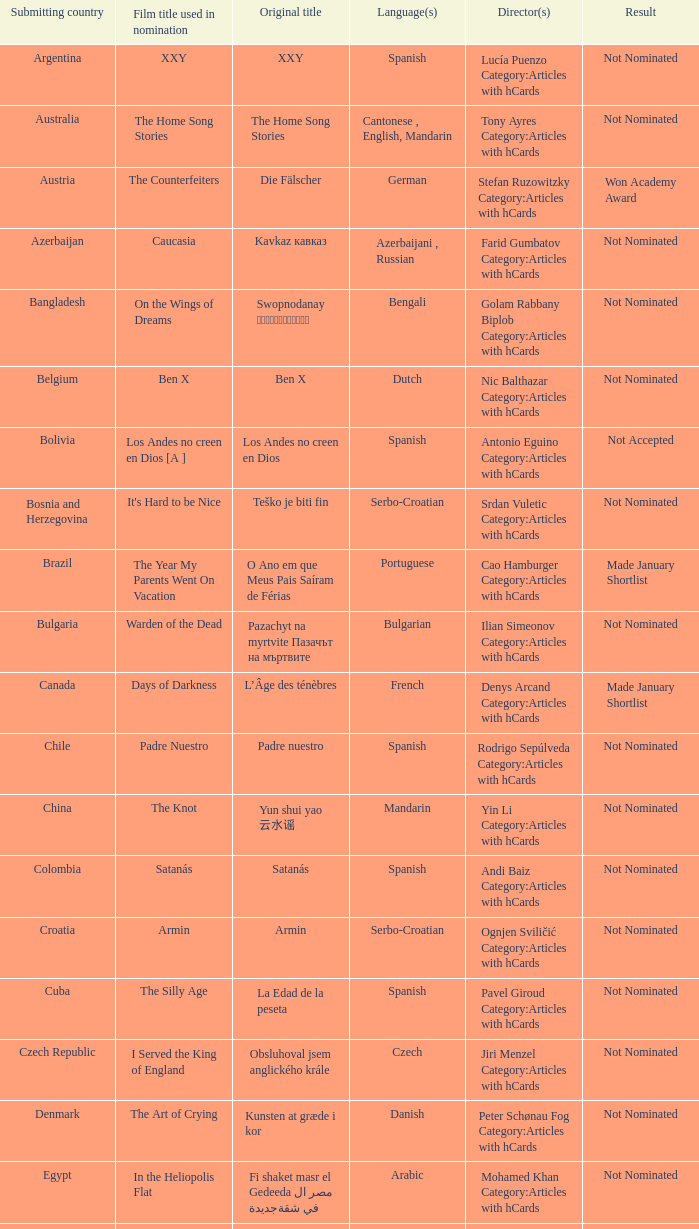What was the heading of the cinema from lebanon? Caramel. 